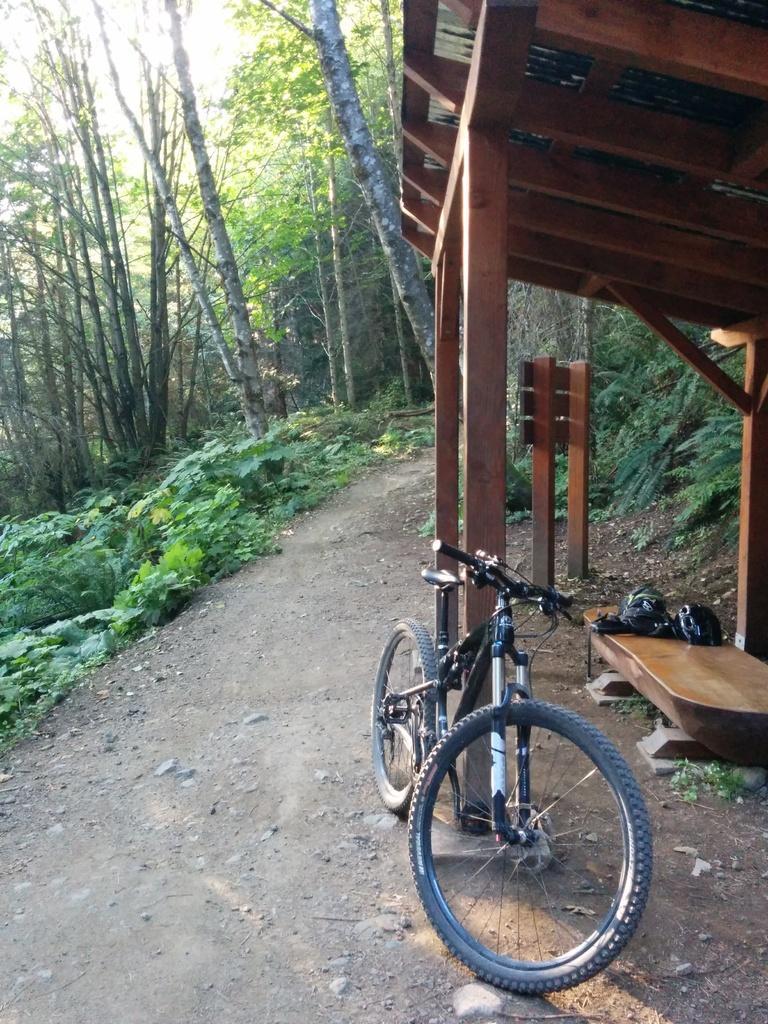Can you describe this image briefly? In this image I can see a bicycle in the front. In the background I can see a shed, a path, grass and number of trees. 